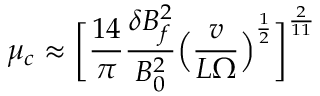<formula> <loc_0><loc_0><loc_500><loc_500>\mu _ { c } \approx \left [ \frac { 1 4 } { \pi } \frac { \delta B _ { f } ^ { 2 } } { B _ { 0 } ^ { 2 } } \left ( \frac { v } { L \Omega } \right ) ^ { \frac { 1 } { 2 } } \right ] ^ { \frac { 2 } { 1 1 } }</formula> 